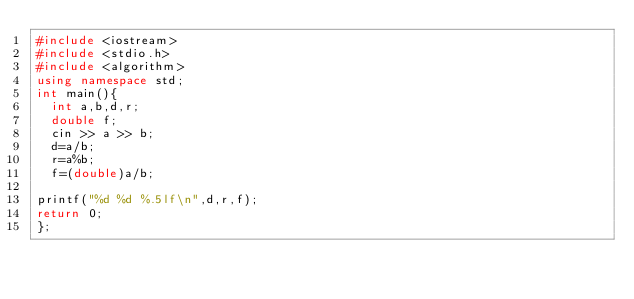<code> <loc_0><loc_0><loc_500><loc_500><_C++_>#include <iostream>
#include <stdio.h>
#include <algorithm>
using namespace std;
int main(){
	int a,b,d,r;
	double f;
	cin >> a >> b;
	d=a/b;
	r=a%b;
	f=(double)a/b;
	
printf("%d %d %.5lf\n",d,r,f);
return 0;
};</code> 